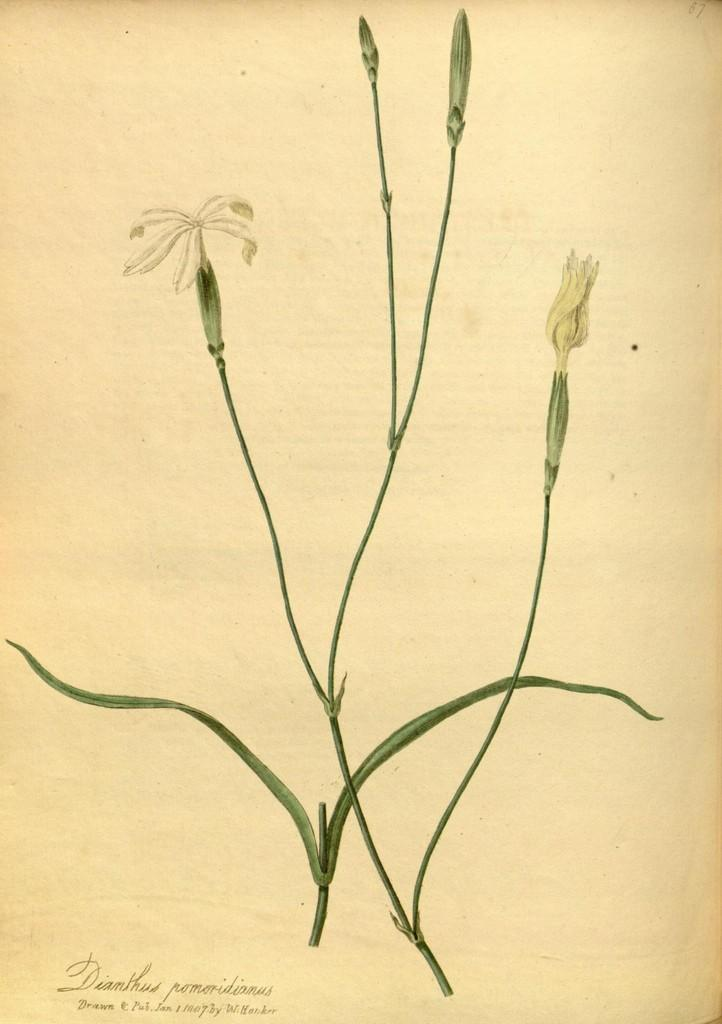What is present in the image that contains both text and images? There is a poster in the image that contains text and images. Can you describe the content of the poster? The poster contains text and images, but the specific content cannot be determined from the provided facts. How many spiders are crawling on the scissors in the image? There are no spiders or scissors present in the image; it only contains a poster with text and images. 